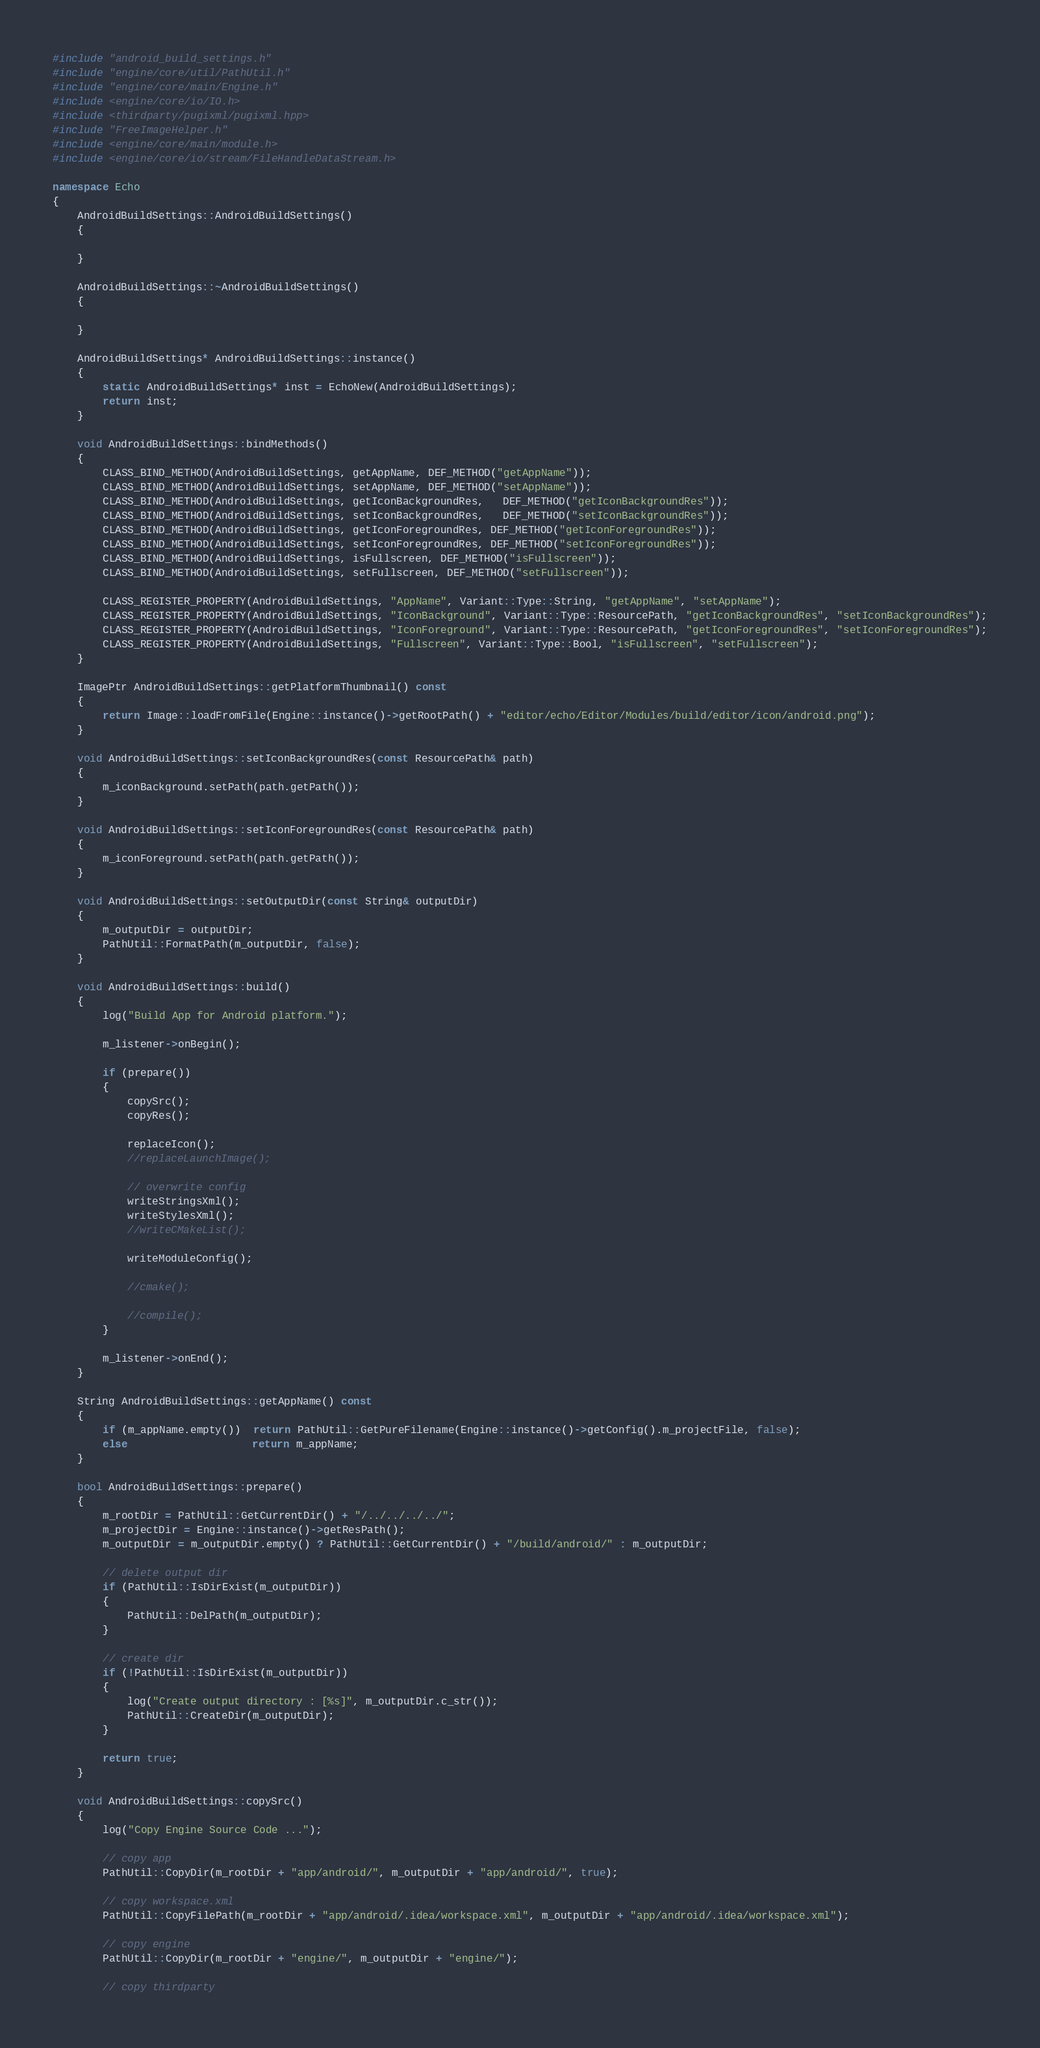Convert code to text. <code><loc_0><loc_0><loc_500><loc_500><_C++_>#include "android_build_settings.h"
#include "engine/core/util/PathUtil.h"
#include "engine/core/main/Engine.h"
#include <engine/core/io/IO.h>
#include <thirdparty/pugixml/pugixml.hpp>
#include "FreeImageHelper.h"
#include <engine/core/main/module.h>
#include <engine/core/io/stream/FileHandleDataStream.h>

namespace Echo
{
    AndroidBuildSettings::AndroidBuildSettings()
    {
    
    }

    AndroidBuildSettings::~AndroidBuildSettings()
    {
        
    }

    AndroidBuildSettings* AndroidBuildSettings::instance()
    {
        static AndroidBuildSettings* inst = EchoNew(AndroidBuildSettings);
        return inst;
    }

    void AndroidBuildSettings::bindMethods()
    {
		CLASS_BIND_METHOD(AndroidBuildSettings, getAppName, DEF_METHOD("getAppName"));
		CLASS_BIND_METHOD(AndroidBuildSettings, setAppName, DEF_METHOD("setAppName"));
        CLASS_BIND_METHOD(AndroidBuildSettings, getIconBackgroundRes,   DEF_METHOD("getIconBackgroundRes"));
        CLASS_BIND_METHOD(AndroidBuildSettings, setIconBackgroundRes,   DEF_METHOD("setIconBackgroundRes"));
		CLASS_BIND_METHOD(AndroidBuildSettings, getIconForegroundRes, DEF_METHOD("getIconForegroundRes"));
		CLASS_BIND_METHOD(AndroidBuildSettings, setIconForegroundRes, DEF_METHOD("setIconForegroundRes"));
		CLASS_BIND_METHOD(AndroidBuildSettings, isFullscreen, DEF_METHOD("isFullscreen"));
		CLASS_BIND_METHOD(AndroidBuildSettings, setFullscreen, DEF_METHOD("setFullscreen"));

		CLASS_REGISTER_PROPERTY(AndroidBuildSettings, "AppName", Variant::Type::String, "getAppName", "setAppName");
        CLASS_REGISTER_PROPERTY(AndroidBuildSettings, "IconBackground", Variant::Type::ResourcePath, "getIconBackgroundRes", "setIconBackgroundRes");
		CLASS_REGISTER_PROPERTY(AndroidBuildSettings, "IconForeground", Variant::Type::ResourcePath, "getIconForegroundRes", "setIconForegroundRes");
		CLASS_REGISTER_PROPERTY(AndroidBuildSettings, "Fullscreen", Variant::Type::Bool, "isFullscreen", "setFullscreen");
    }

	ImagePtr AndroidBuildSettings::getPlatformThumbnail() const
	{
		return Image::loadFromFile(Engine::instance()->getRootPath() + "editor/echo/Editor/Modules/build/editor/icon/android.png");
	}

    void AndroidBuildSettings::setIconBackgroundRes(const ResourcePath& path)
    {
		m_iconBackground.setPath(path.getPath());
    }

	void AndroidBuildSettings::setIconForegroundRes(const ResourcePath& path)
	{
		m_iconForeground.setPath(path.getPath());
	}

    void AndroidBuildSettings::setOutputDir(const String& outputDir)
    {
		m_outputDir = outputDir;
		PathUtil::FormatPath(m_outputDir, false);
    }

    void AndroidBuildSettings::build()
    {
		log("Build App for Android platform.");

		m_listener->onBegin();

		if (prepare())
		{
			copySrc();
			copyRes();

			replaceIcon();
			//replaceLaunchImage();

			// overwrite config
			writeStringsXml();
			writeStylesXml();
			//writeCMakeList();

			writeModuleConfig();

			//cmake();

			//compile();
		}

		m_listener->onEnd();
    }

	String AndroidBuildSettings::getAppName() const
	{
		if (m_appName.empty())  return PathUtil::GetPureFilename(Engine::instance()->getConfig().m_projectFile, false);
		else                    return m_appName;
	}

    bool AndroidBuildSettings::prepare()
    {
		m_rootDir = PathUtil::GetCurrentDir() + "/../../../../";
		m_projectDir = Engine::instance()->getResPath();
        m_outputDir = m_outputDir.empty() ? PathUtil::GetCurrentDir() + "/build/android/" : m_outputDir;

		// delete output dir
		if (PathUtil::IsDirExist(m_outputDir))
		{
			PathUtil::DelPath(m_outputDir);
		}

		// create dir
		if (!PathUtil::IsDirExist(m_outputDir))
		{
			log("Create output directory : [%s]", m_outputDir.c_str());
			PathUtil::CreateDir(m_outputDir);
		}

        return true;
    }

    void AndroidBuildSettings::copySrc()
    {
		log("Copy Engine Source Code ...");

		// copy app
		PathUtil::CopyDir(m_rootDir + "app/android/", m_outputDir + "app/android/", true);

		// copy workspace.xml
		PathUtil::CopyFilePath(m_rootDir + "app/android/.idea/workspace.xml", m_outputDir + "app/android/.idea/workspace.xml");

		// copy engine
		PathUtil::CopyDir(m_rootDir + "engine/", m_outputDir + "engine/");

		// copy thirdparty</code> 